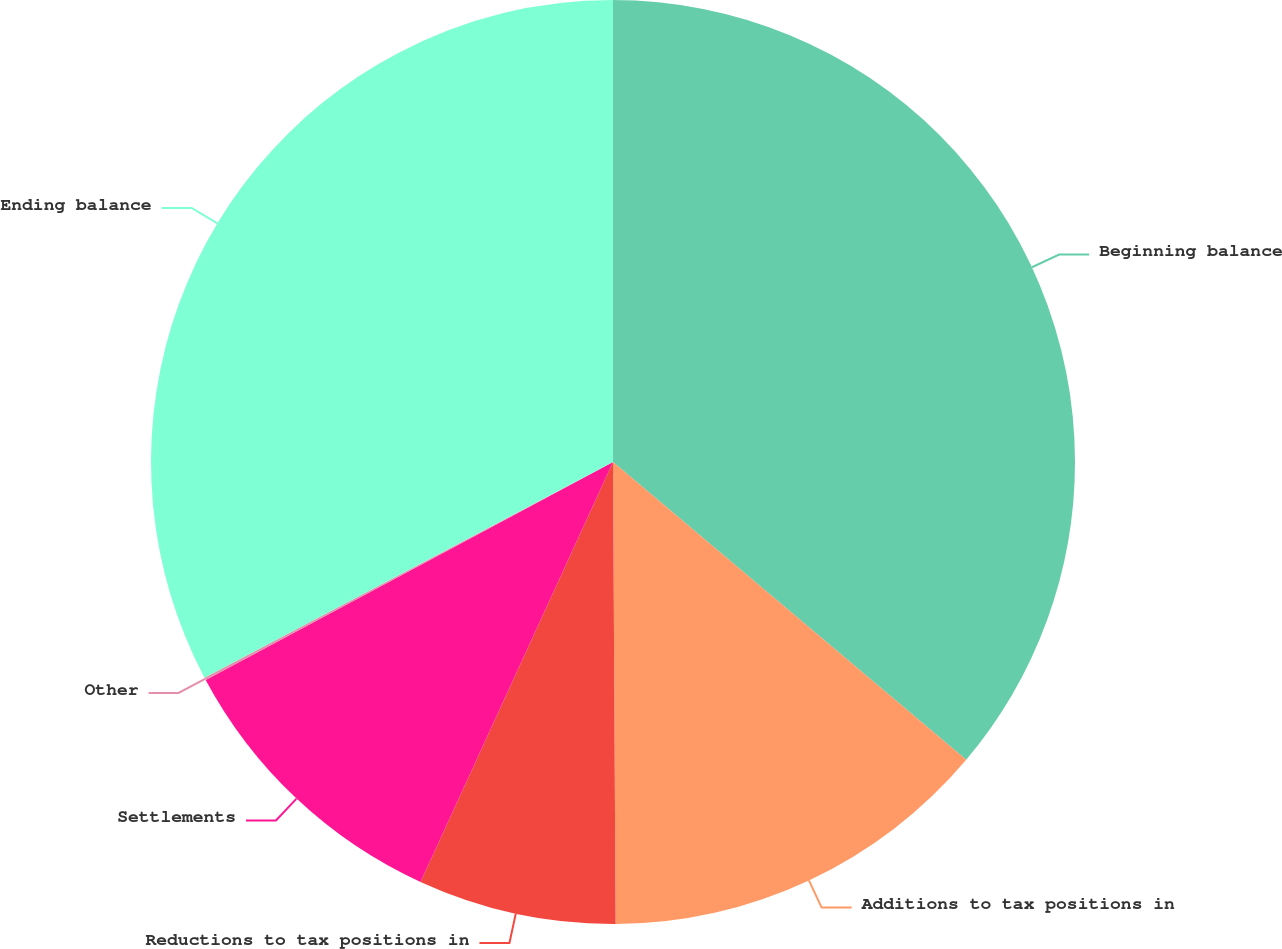<chart> <loc_0><loc_0><loc_500><loc_500><pie_chart><fcel>Beginning balance<fcel>Additions to tax positions in<fcel>Reductions to tax positions in<fcel>Settlements<fcel>Other<fcel>Ending balance<nl><fcel>36.15%<fcel>13.76%<fcel>6.93%<fcel>10.34%<fcel>0.09%<fcel>32.73%<nl></chart> 